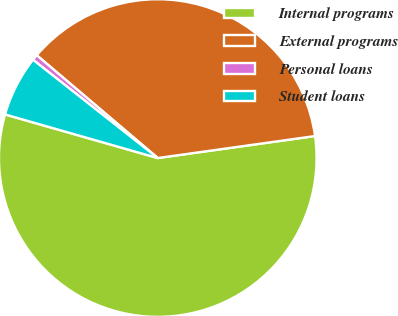<chart> <loc_0><loc_0><loc_500><loc_500><pie_chart><fcel>Internal programs<fcel>External programs<fcel>Personal loans<fcel>Student loans<nl><fcel>56.64%<fcel>36.58%<fcel>0.59%<fcel>6.19%<nl></chart> 